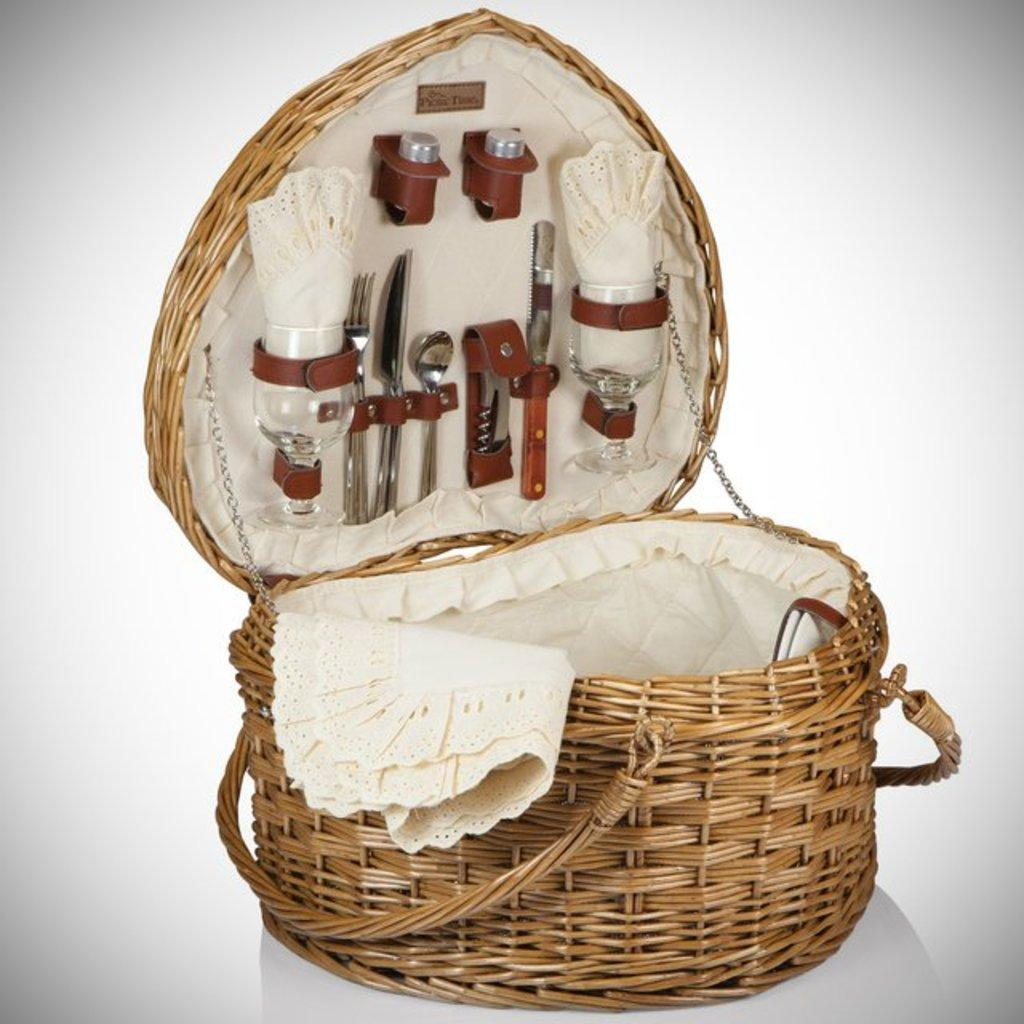What object is present in the image that can hold items? There is a basket in the image that can hold items. What types of items are inside the basket? The basket contains glasses, spoons, a knife, a fork, and a cloth. What is the color of the surface in the image? The image has a white surface. What is the color of the background in the image? The image has a white background. What type of soap is being used by the maid in the image? There is no soap or maid present in the image; it features a basket with various items on a white surface and white background. 